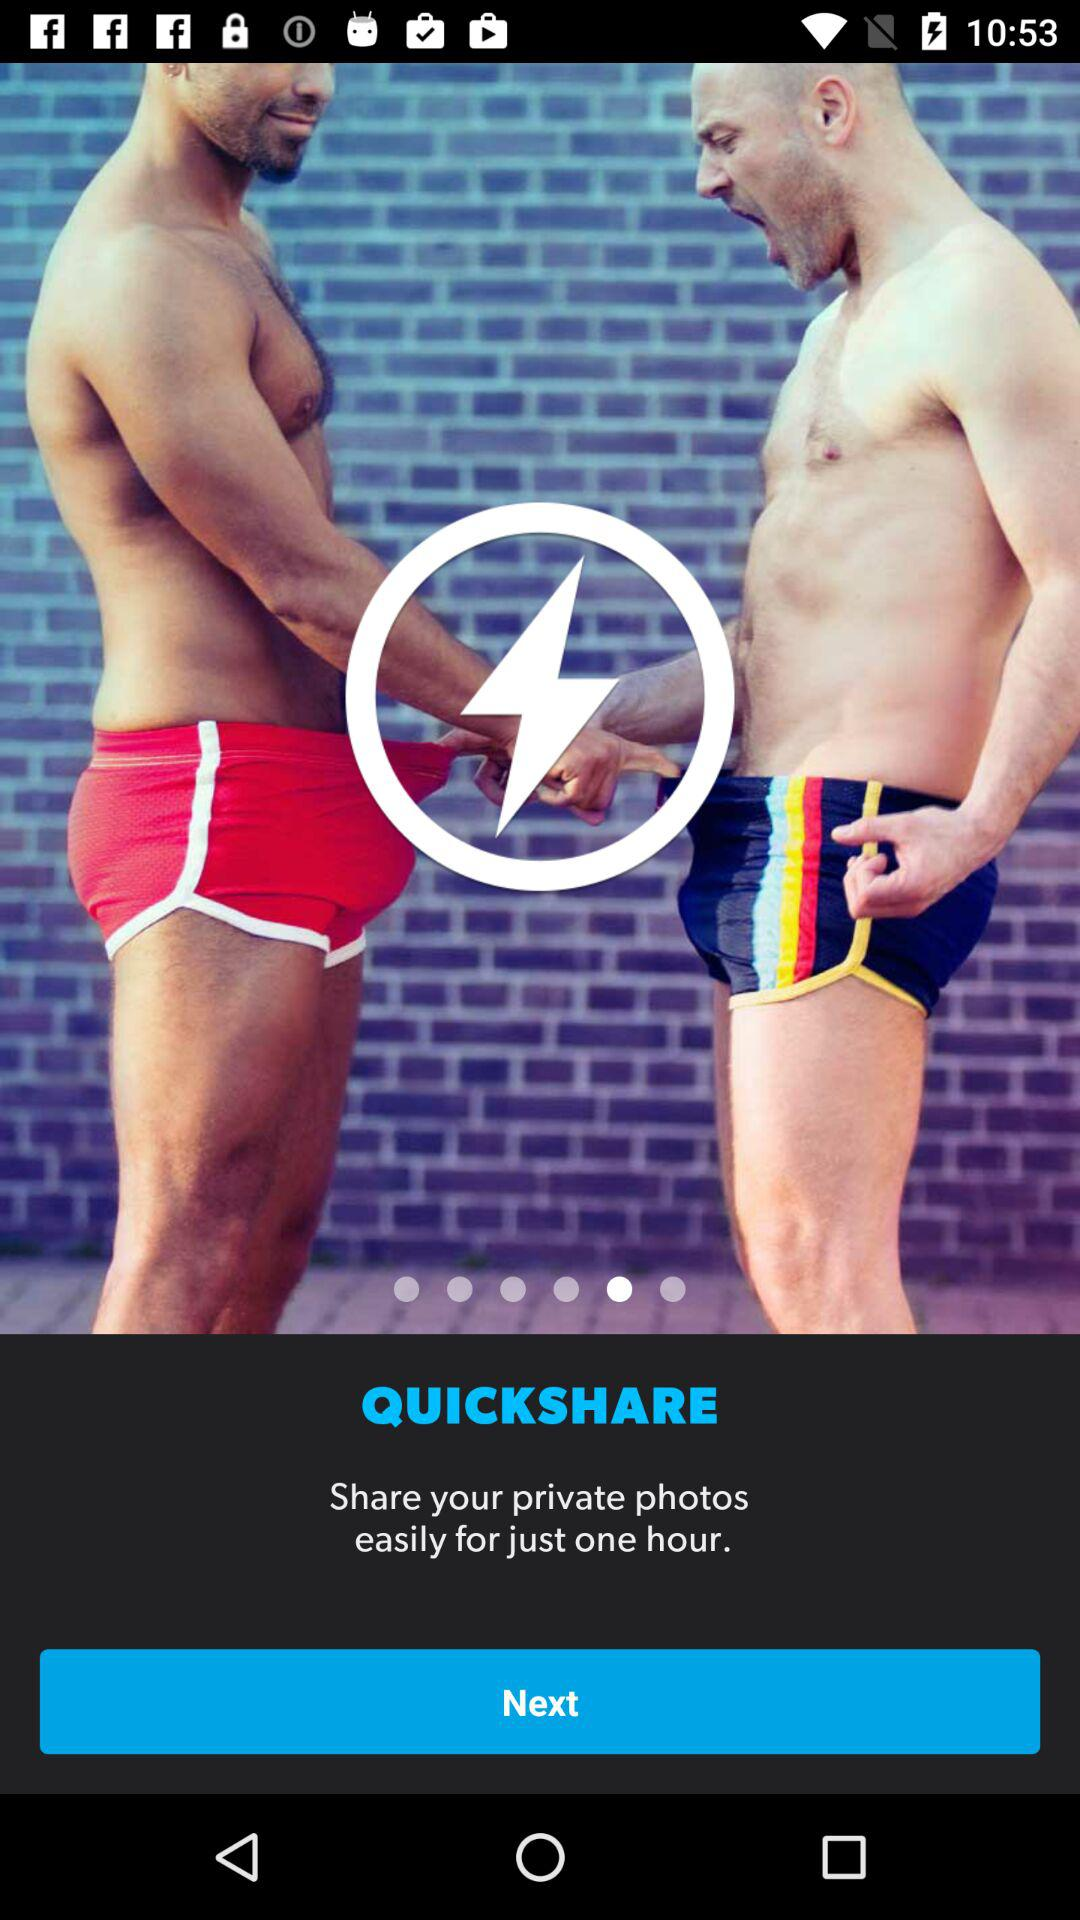What is the name of the application? The name of the application is "QUICKSHARE". 